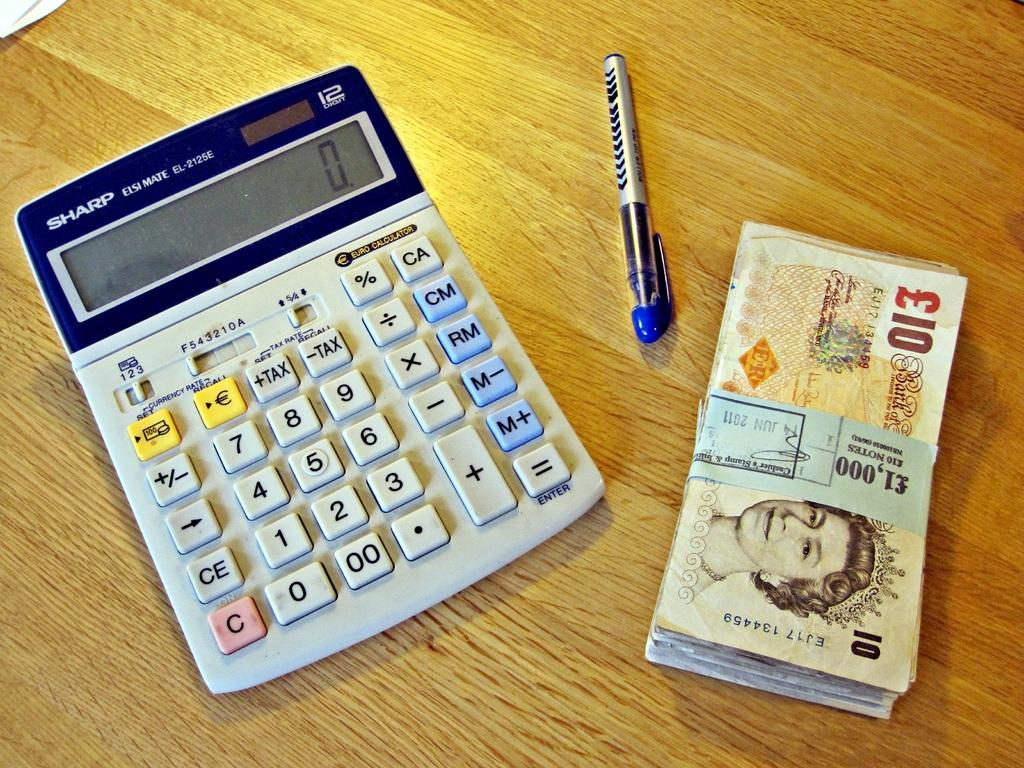<image>
Write a terse but informative summary of the picture. A Sharp calculator, a pen and a stack of cash sit on a desk. 